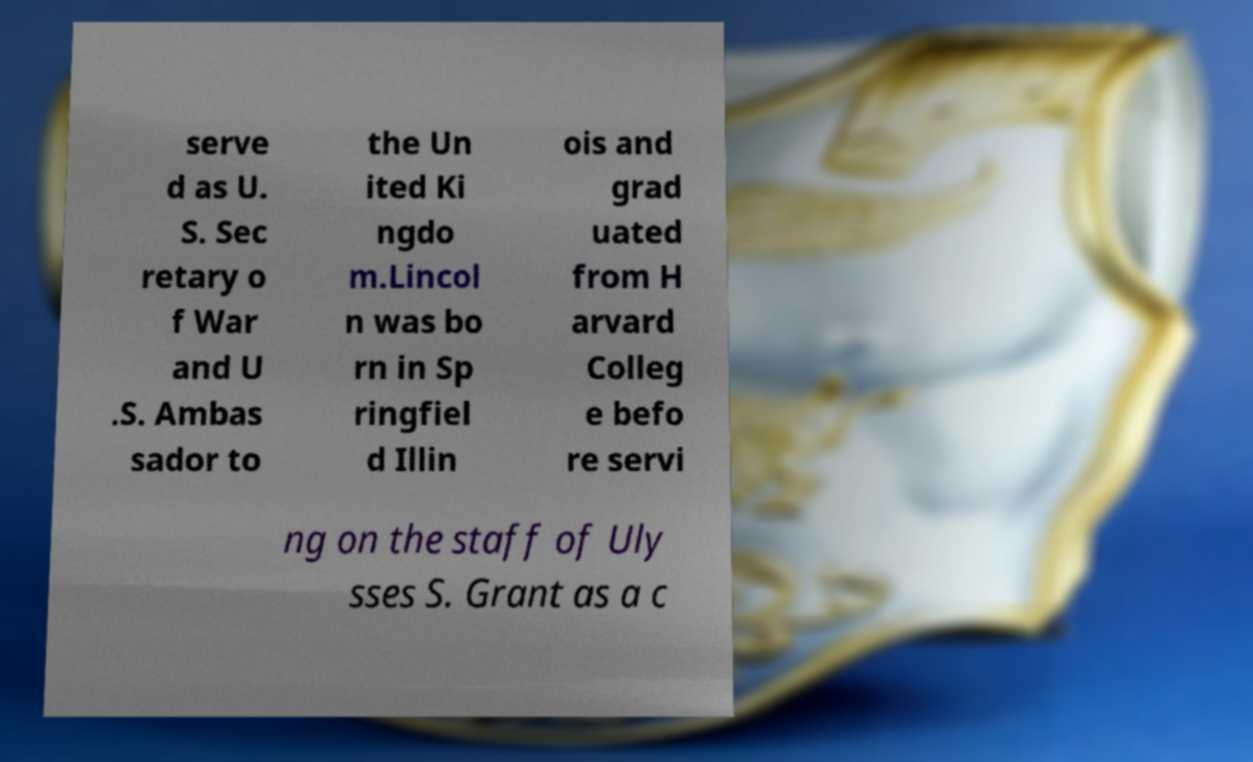Could you extract and type out the text from this image? serve d as U. S. Sec retary o f War and U .S. Ambas sador to the Un ited Ki ngdo m.Lincol n was bo rn in Sp ringfiel d Illin ois and grad uated from H arvard Colleg e befo re servi ng on the staff of Uly sses S. Grant as a c 